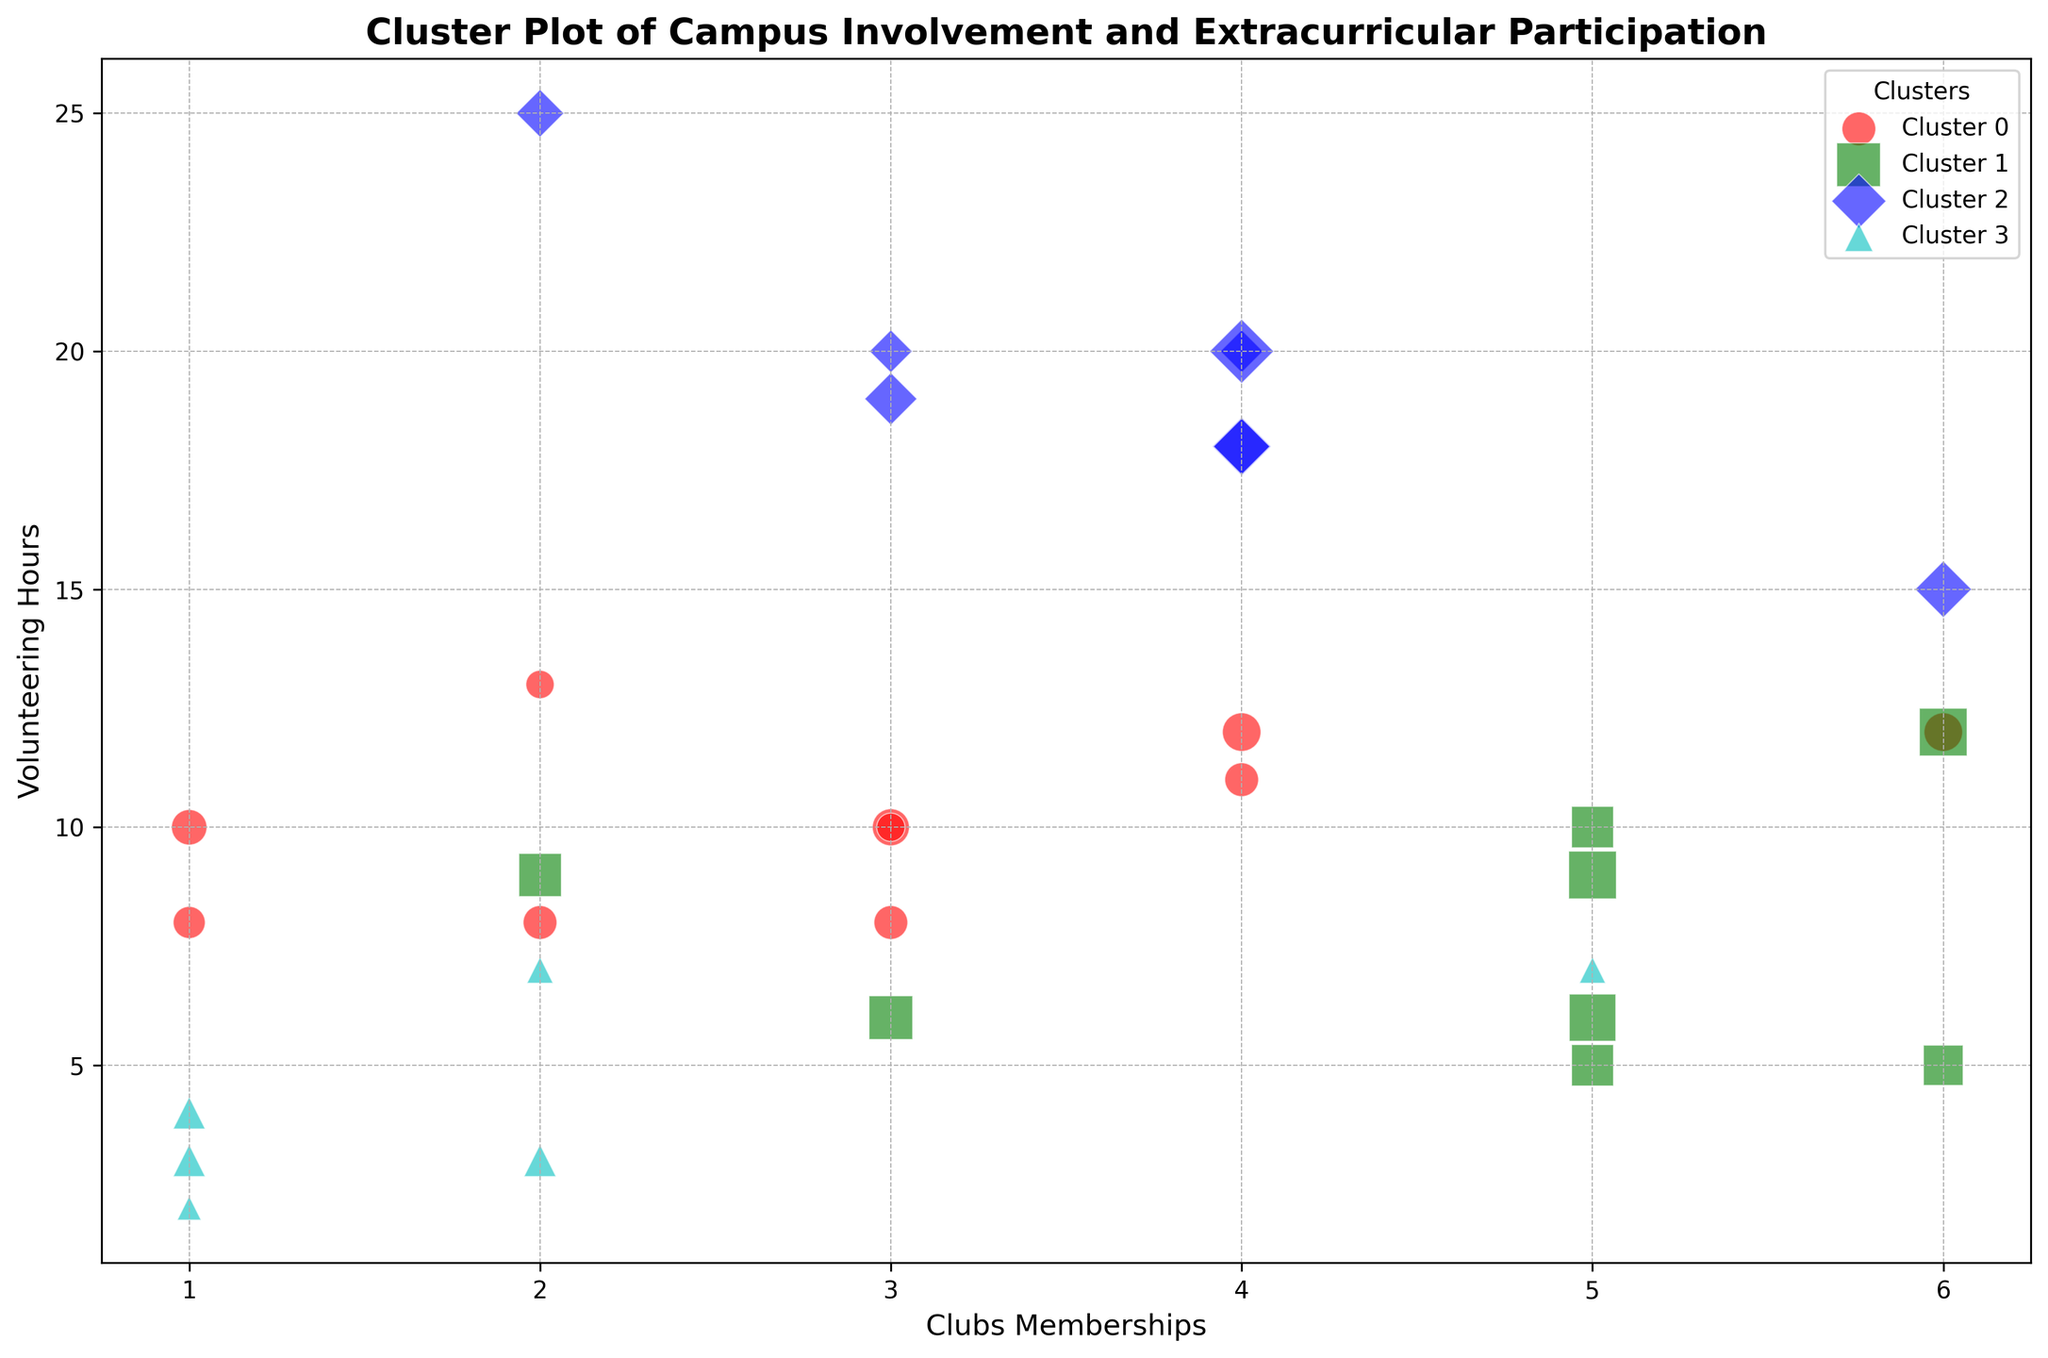How many freshmen are in cluster 1? First, identify which data points are in Cluster 1 by looking at their color and marker, then count the number of points that correspond to freshmen.
Answer: 1 Which cluster contains the student with the highest number of volunteering hours? Identify which cluster has the point at the highest value on the y-axis (Volunteering Hours). Check the cluster label.
Answer: Cluster 1 Which cluster has the most varied range of clubs memberships? Compare the range of x-values (Clubs Memberships) within each cluster. The cluster with the widest range has the most varied range of clubs memberships.
Answer: Cluster 1 Which cluster has the smallest number of events attended on average? Calculate the average size (representing Events Attended) for each cluster's data points and identify the cluster with the smallest average size.
Answer: Cluster 0 Which cluster appears most involved based on the combined visual attributes? Observe the cluster with the largest relative sizes, highest number of clubs memberships, and volunteering hours.
Answer: Cluster 1 What is the average number of clubs memberships for students in cluster 3? Sum the x-values (Clubs Memberships) for all points in cluster 3 and divide by the number of points in the cluster.
Answer: 3.125 Compare the distribution of volunteering hours between clusters 0 and 2. Which cluster has higher volunteering hours on average? Compare the y-values (Volunteering Hours) of clusters 0 and 2; find the average for each cluster and compare them.
Answer: Cluster 2 What can you infer about the extracurricular involvement of students in cluster 2 compared to cluster 3? Visually compare cluster 2 (with more memberships and higher volunteering hours on average) with cluster 3, which might show different distribution characteristics.
Answer: Cluster 2 is likely more involved in clubs and volunteering Which cluster has the least number of sports teams participants? Count the z-values (Sports Teams) in each cluster and identify the one with the least total.
Answer: Cluster 0 What is the common trend in clubs memberships for students in cluster 1? Observe the x-values (Clubs Memberships) for points in cluster 1 to identify if there is a common range or trend.
Answer: High clubs memberships are common 